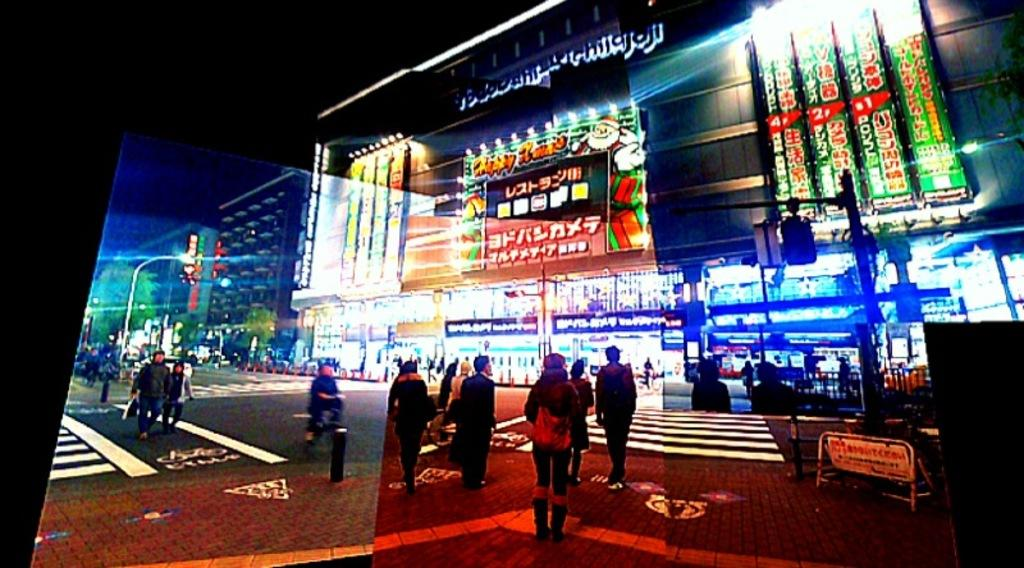What is the main subject of the image? The main subject of the image is many people on the road. What can be seen in the background of the image? There are many buildings in the background of the image. Are there any natural elements in the image? Yes, there is a tree in the image. What might be used to control traffic or block access in the image? There are barricades in the image. How are these elements being displayed? All these elements are displayed on a screen. What type of ice can be seen melting on the tree in the image? There is no ice present on the tree in the image. How many ants can be seen crawling on the buildings in the image? There are no ants visible on the buildings in the image. 